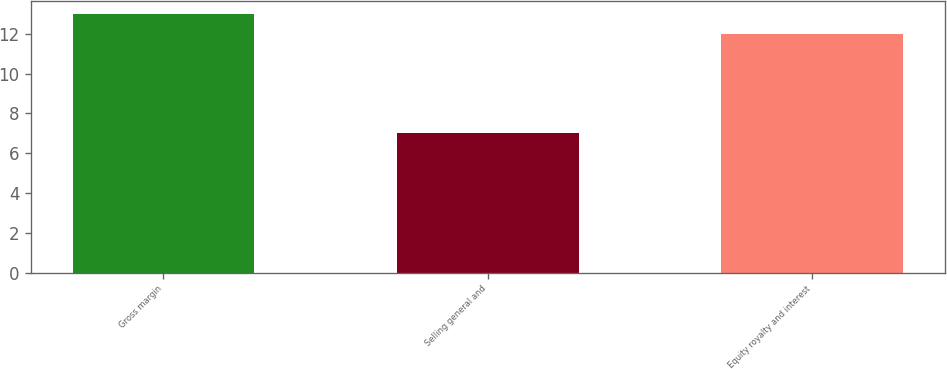<chart> <loc_0><loc_0><loc_500><loc_500><bar_chart><fcel>Gross margin<fcel>Selling general and<fcel>Equity royalty and interest<nl><fcel>13<fcel>7<fcel>12<nl></chart> 